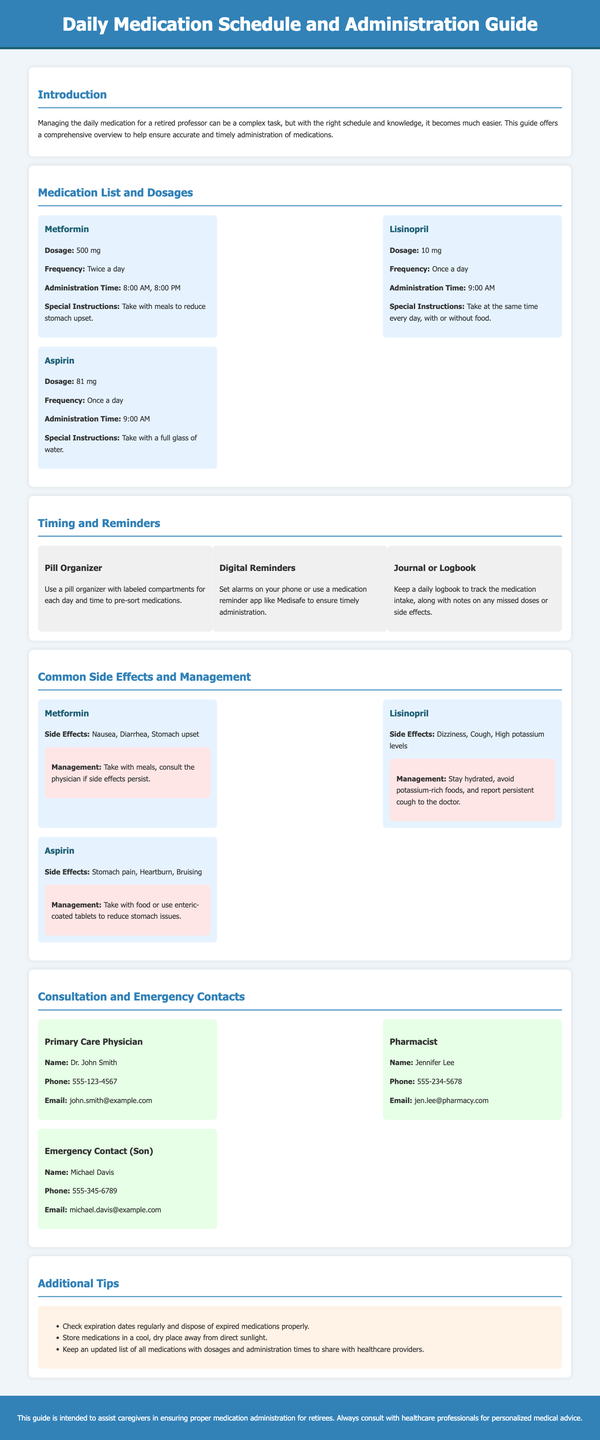What is the dosage of Metformin? The dosage of Metformin is specified in the medication list, which states it is 500 mg.
Answer: 500 mg How often should Lisinopril be taken? The frequency for Lisinopril is mentioned as once a day in the medication list.
Answer: Once a day What are the side effects of Aspirin? The side effects for Aspirin are listed in the common side effects section.
Answer: Stomach pain, Heartburn, Bruising What time should Metformin be administered? The administration time for Metformin is provided, which is 8:00 AM and 8:00 PM.
Answer: 8:00 AM, 8:00 PM Who is the primary care physician? The primary care physician's name is available in the consultation and emergency contacts section.
Answer: Dr. John Smith What should be used to reduce stomach upset from Metformin? The special instructions for Metformin suggest taking it with meals to reduce stomach upset.
Answer: Take with meals What digital tool is recommended for medication reminders? The document mentions using a medication reminder app like Medisafe for timely administration.
Answer: Medisafe How many medications are listed in the medication list? The medication list contains three medications as detailed in the section.
Answer: Three medications 